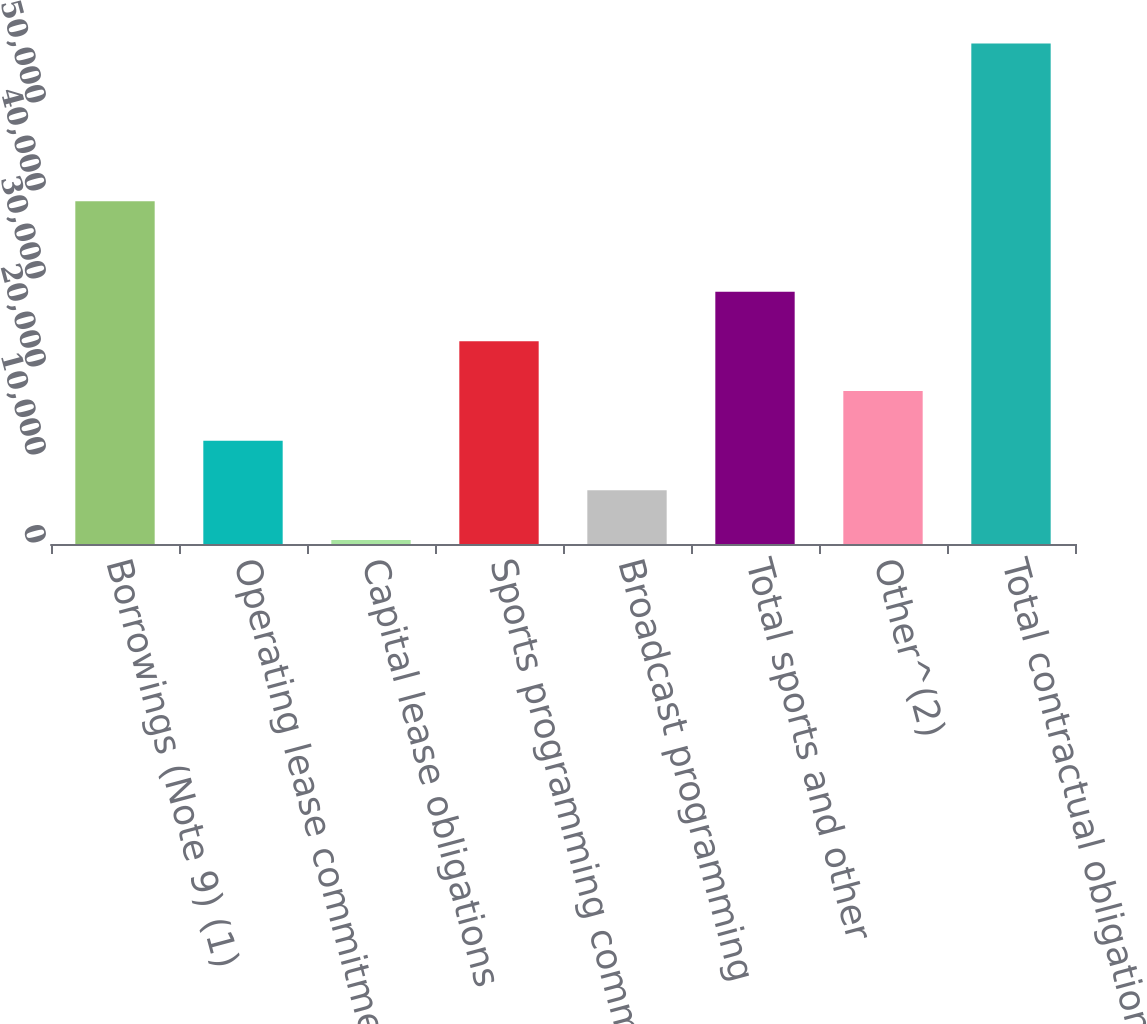Convert chart. <chart><loc_0><loc_0><loc_500><loc_500><bar_chart><fcel>Borrowings (Note 9) (1)<fcel>Operating lease commitments<fcel>Capital lease obligations<fcel>Sports programming commitments<fcel>Broadcast programming<fcel>Total sports and other<fcel>Other^(2)<fcel>Total contractual obligations<nl><fcel>38953<fcel>11743.6<fcel>458<fcel>23029.2<fcel>6100.8<fcel>28672<fcel>17386.4<fcel>56886<nl></chart> 